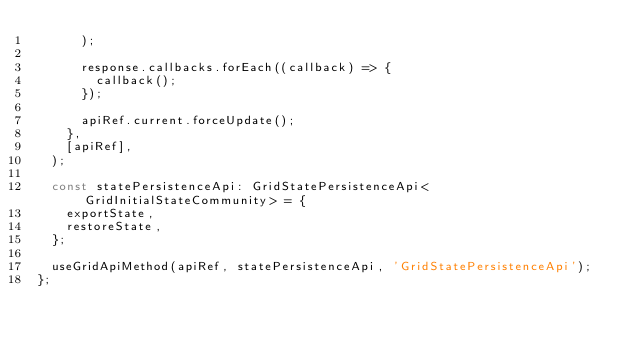<code> <loc_0><loc_0><loc_500><loc_500><_TypeScript_>      );

      response.callbacks.forEach((callback) => {
        callback();
      });

      apiRef.current.forceUpdate();
    },
    [apiRef],
  );

  const statePersistenceApi: GridStatePersistenceApi<GridInitialStateCommunity> = {
    exportState,
    restoreState,
  };

  useGridApiMethod(apiRef, statePersistenceApi, 'GridStatePersistenceApi');
};
</code> 